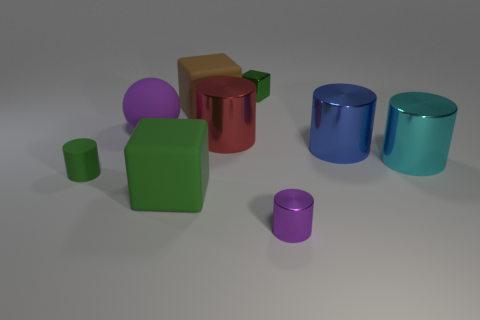How many green objects are the same material as the brown object?
Provide a short and direct response. 2. How many objects are either large brown matte cubes or small things in front of the big purple thing?
Ensure brevity in your answer.  3. Do the green object behind the large purple rubber thing and the ball have the same material?
Ensure brevity in your answer.  No. There is a ball that is the same size as the red shiny thing; what is its color?
Give a very brief answer. Purple. Is there a big object that has the same shape as the small matte object?
Provide a short and direct response. Yes. There is a small shiny object that is behind the purple metallic object that is on the right side of the big metallic thing on the left side of the green shiny object; what color is it?
Your answer should be very brief. Green. How many metal things are purple balls or brown cylinders?
Provide a short and direct response. 0. Are there more shiny things that are in front of the blue cylinder than matte objects right of the large red cylinder?
Make the answer very short. Yes. How many other objects are the same size as the red metal object?
Give a very brief answer. 5. There is a matte cube that is right of the green block that is in front of the purple rubber object; what size is it?
Offer a very short reply. Large. 